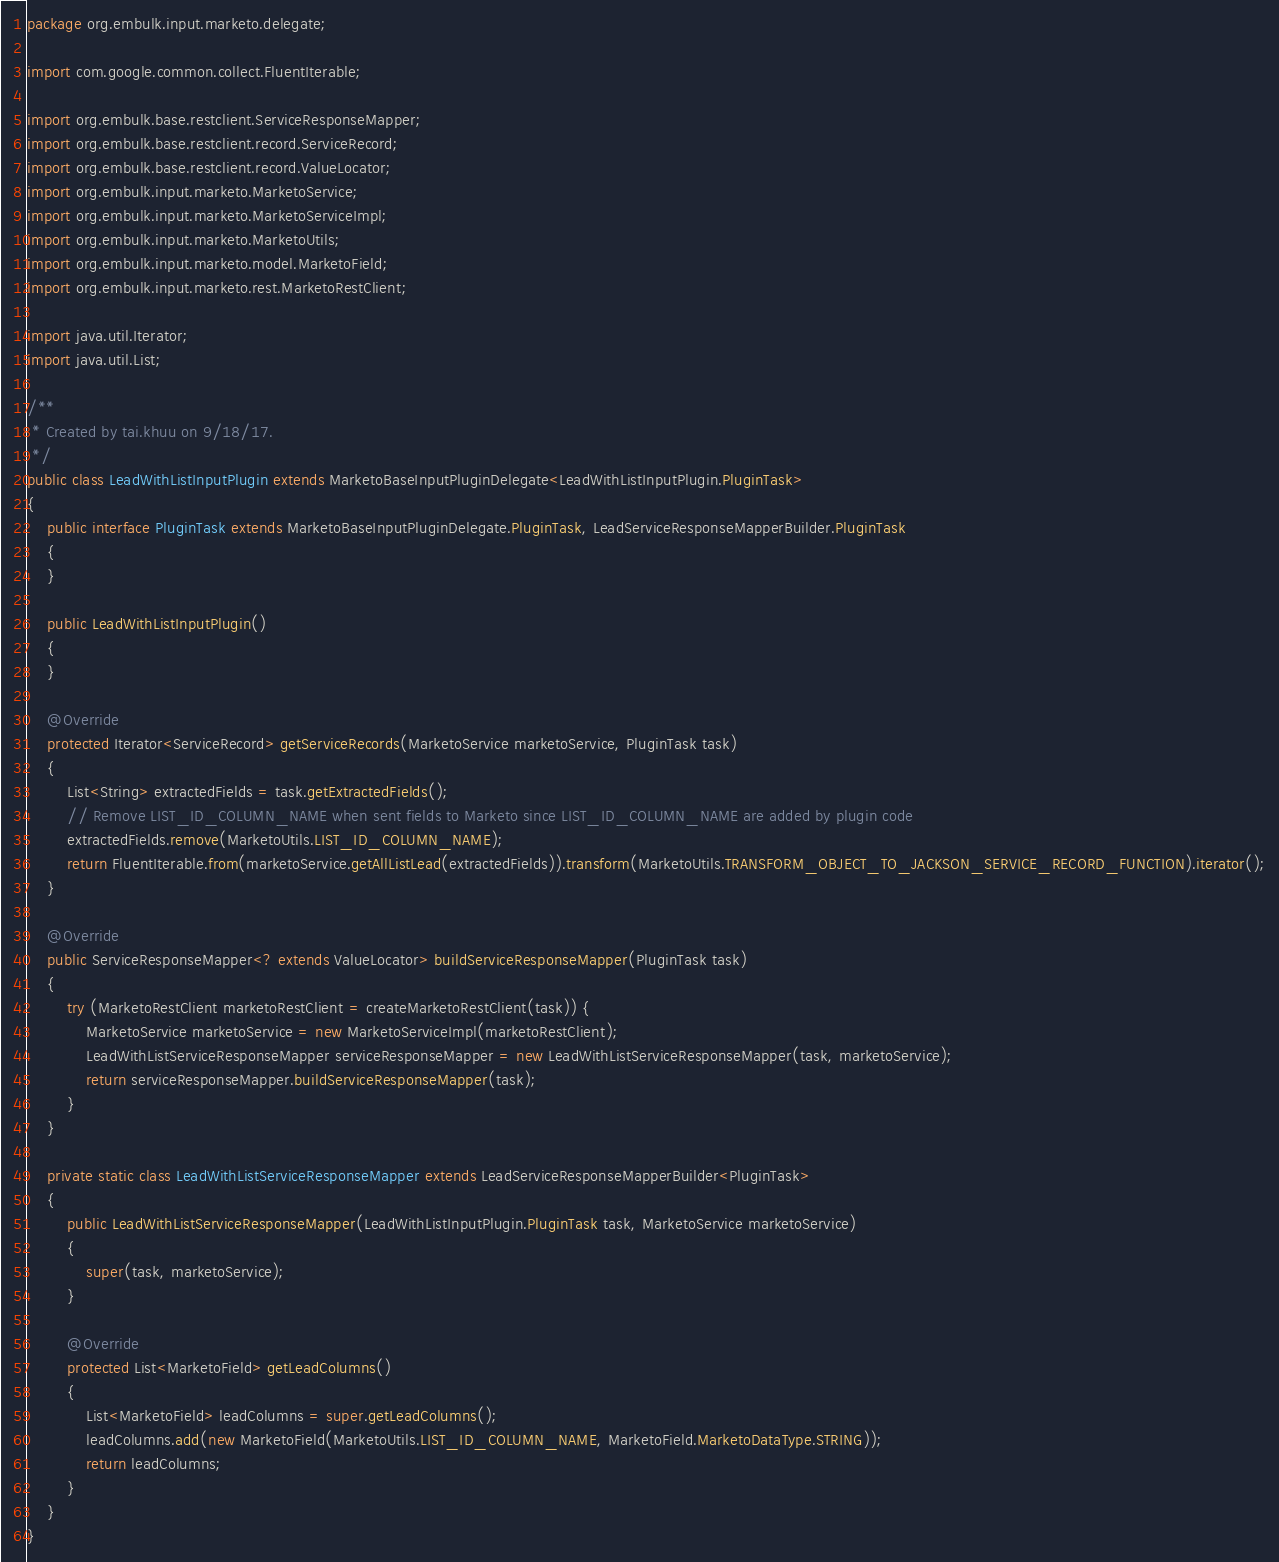<code> <loc_0><loc_0><loc_500><loc_500><_Java_>package org.embulk.input.marketo.delegate;

import com.google.common.collect.FluentIterable;

import org.embulk.base.restclient.ServiceResponseMapper;
import org.embulk.base.restclient.record.ServiceRecord;
import org.embulk.base.restclient.record.ValueLocator;
import org.embulk.input.marketo.MarketoService;
import org.embulk.input.marketo.MarketoServiceImpl;
import org.embulk.input.marketo.MarketoUtils;
import org.embulk.input.marketo.model.MarketoField;
import org.embulk.input.marketo.rest.MarketoRestClient;

import java.util.Iterator;
import java.util.List;

/**
 * Created by tai.khuu on 9/18/17.
 */
public class LeadWithListInputPlugin extends MarketoBaseInputPluginDelegate<LeadWithListInputPlugin.PluginTask>
{
    public interface PluginTask extends MarketoBaseInputPluginDelegate.PluginTask, LeadServiceResponseMapperBuilder.PluginTask
    {
    }

    public LeadWithListInputPlugin()
    {
    }

    @Override
    protected Iterator<ServiceRecord> getServiceRecords(MarketoService marketoService, PluginTask task)
    {
        List<String> extractedFields = task.getExtractedFields();
        // Remove LIST_ID_COLUMN_NAME when sent fields to Marketo since LIST_ID_COLUMN_NAME are added by plugin code
        extractedFields.remove(MarketoUtils.LIST_ID_COLUMN_NAME);
        return FluentIterable.from(marketoService.getAllListLead(extractedFields)).transform(MarketoUtils.TRANSFORM_OBJECT_TO_JACKSON_SERVICE_RECORD_FUNCTION).iterator();
    }

    @Override
    public ServiceResponseMapper<? extends ValueLocator> buildServiceResponseMapper(PluginTask task)
    {
        try (MarketoRestClient marketoRestClient = createMarketoRestClient(task)) {
            MarketoService marketoService = new MarketoServiceImpl(marketoRestClient);
            LeadWithListServiceResponseMapper serviceResponseMapper = new LeadWithListServiceResponseMapper(task, marketoService);
            return serviceResponseMapper.buildServiceResponseMapper(task);
        }
    }

    private static class LeadWithListServiceResponseMapper extends LeadServiceResponseMapperBuilder<PluginTask>
    {
        public LeadWithListServiceResponseMapper(LeadWithListInputPlugin.PluginTask task, MarketoService marketoService)
        {
            super(task, marketoService);
        }

        @Override
        protected List<MarketoField> getLeadColumns()
        {
            List<MarketoField> leadColumns = super.getLeadColumns();
            leadColumns.add(new MarketoField(MarketoUtils.LIST_ID_COLUMN_NAME, MarketoField.MarketoDataType.STRING));
            return leadColumns;
        }
    }
}
</code> 